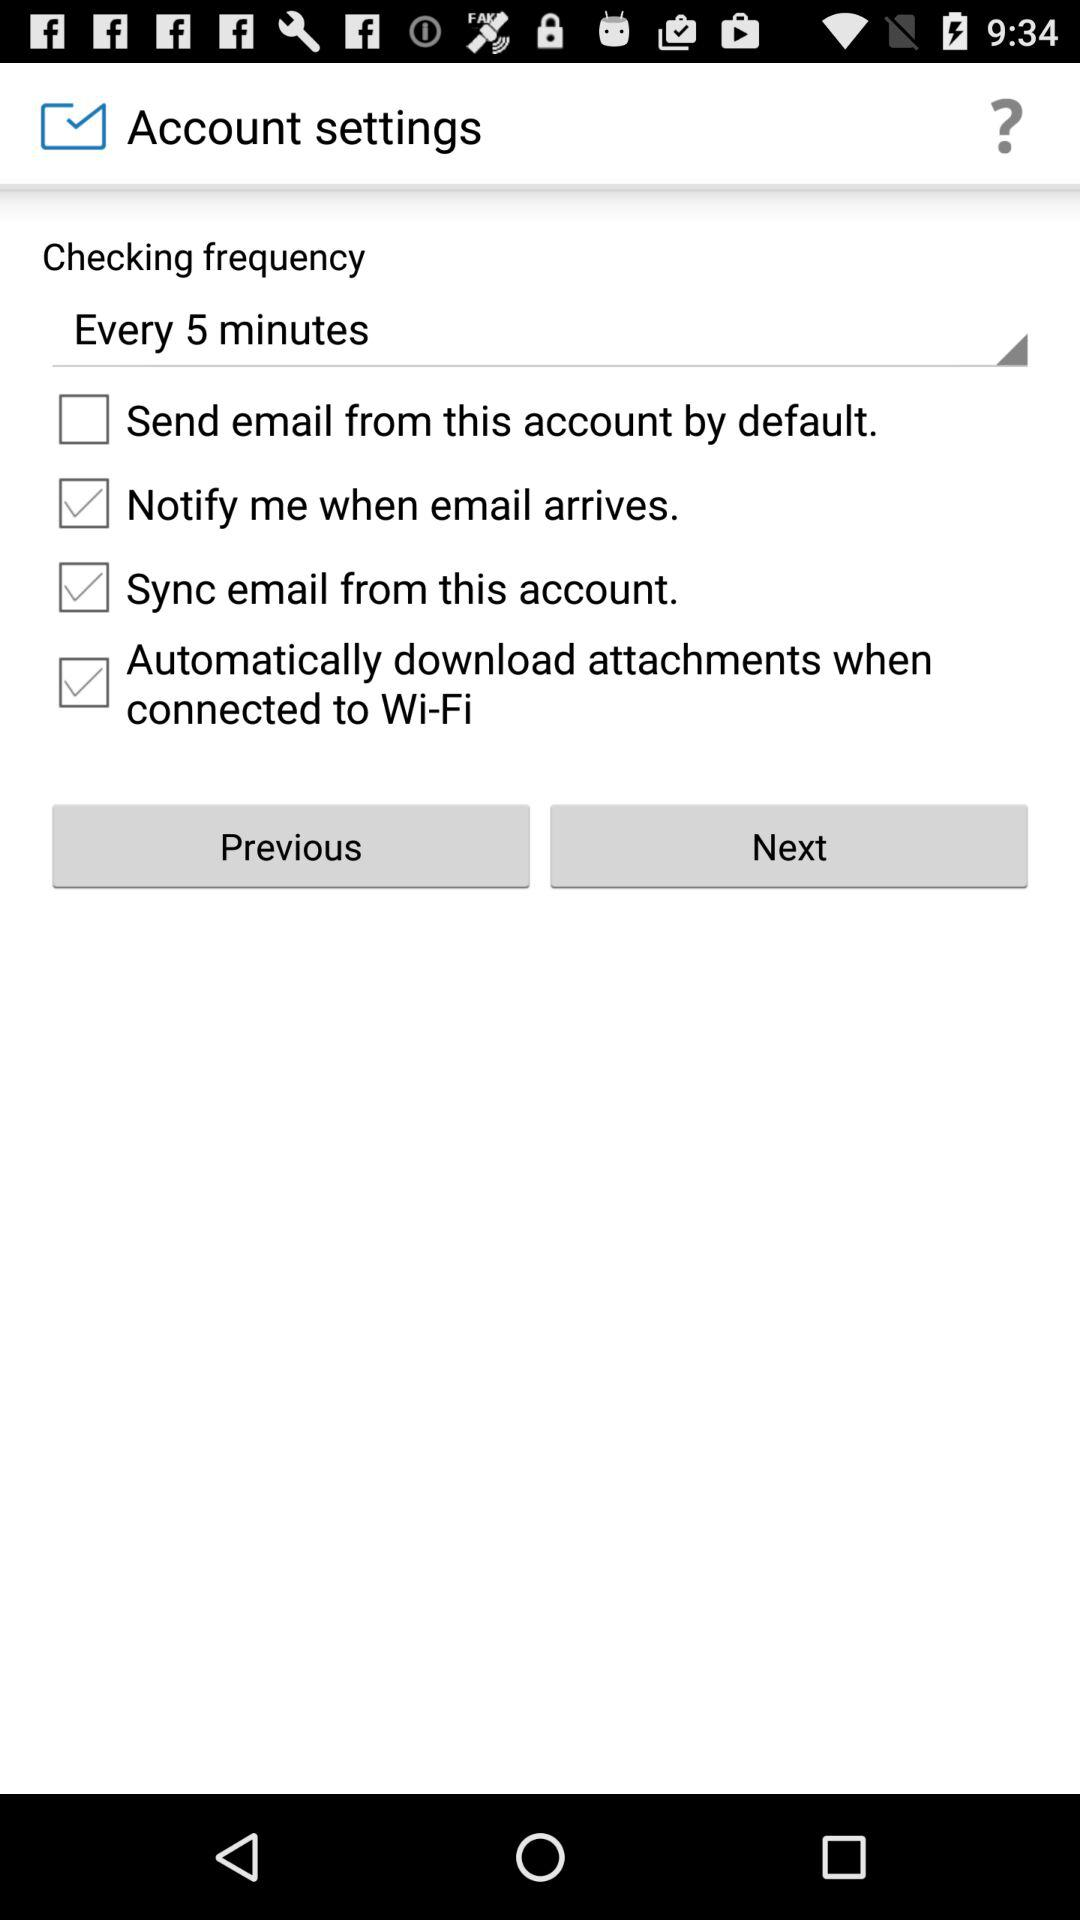What is the "Checking frequency"? The "Checking frequency" is "Every 5 minutes". 